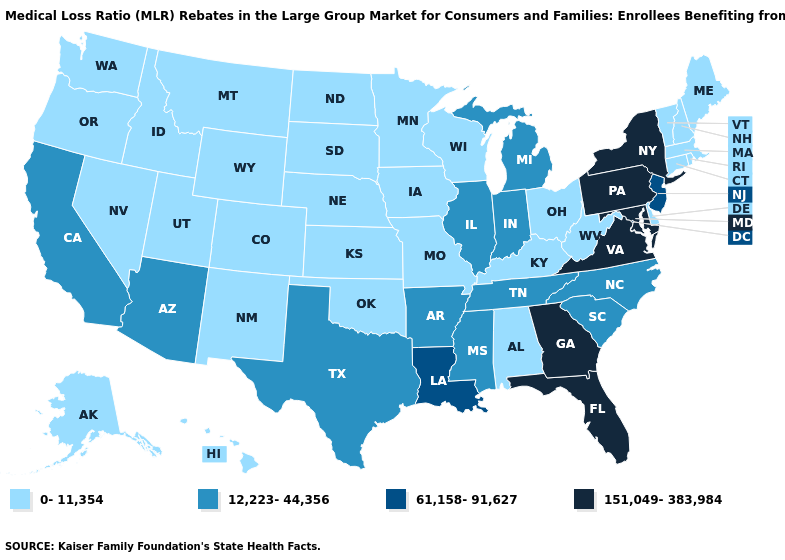Name the states that have a value in the range 0-11,354?
Concise answer only. Alabama, Alaska, Colorado, Connecticut, Delaware, Hawaii, Idaho, Iowa, Kansas, Kentucky, Maine, Massachusetts, Minnesota, Missouri, Montana, Nebraska, Nevada, New Hampshire, New Mexico, North Dakota, Ohio, Oklahoma, Oregon, Rhode Island, South Dakota, Utah, Vermont, Washington, West Virginia, Wisconsin, Wyoming. Does Massachusetts have a lower value than North Dakota?
Be succinct. No. Does Alabama have the lowest value in the USA?
Keep it brief. Yes. What is the value of Indiana?
Quick response, please. 12,223-44,356. What is the value of Texas?
Answer briefly. 12,223-44,356. Does the map have missing data?
Be succinct. No. Does the first symbol in the legend represent the smallest category?
Give a very brief answer. Yes. Which states hav the highest value in the West?
Concise answer only. Arizona, California. Does Nevada have the same value as New Hampshire?
Quick response, please. Yes. Among the states that border West Virginia , does Kentucky have the highest value?
Concise answer only. No. Does the map have missing data?
Quick response, please. No. Among the states that border Virginia , does Maryland have the lowest value?
Answer briefly. No. Does Illinois have the highest value in the USA?
Short answer required. No. Among the states that border Mississippi , which have the highest value?
Concise answer only. Louisiana. Does Nebraska have a lower value than Mississippi?
Give a very brief answer. Yes. 